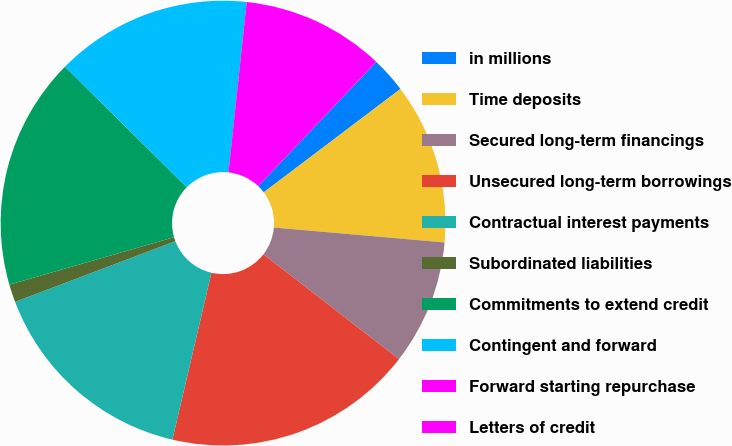<chart> <loc_0><loc_0><loc_500><loc_500><pie_chart><fcel>in millions<fcel>Time deposits<fcel>Secured long-term financings<fcel>Unsecured long-term borrowings<fcel>Contractual interest payments<fcel>Subordinated liabilities<fcel>Commitments to extend credit<fcel>Contingent and forward<fcel>Forward starting repurchase<fcel>Letters of credit<nl><fcel>2.6%<fcel>11.69%<fcel>9.09%<fcel>18.18%<fcel>15.58%<fcel>1.3%<fcel>16.88%<fcel>14.28%<fcel>10.39%<fcel>0.01%<nl></chart> 